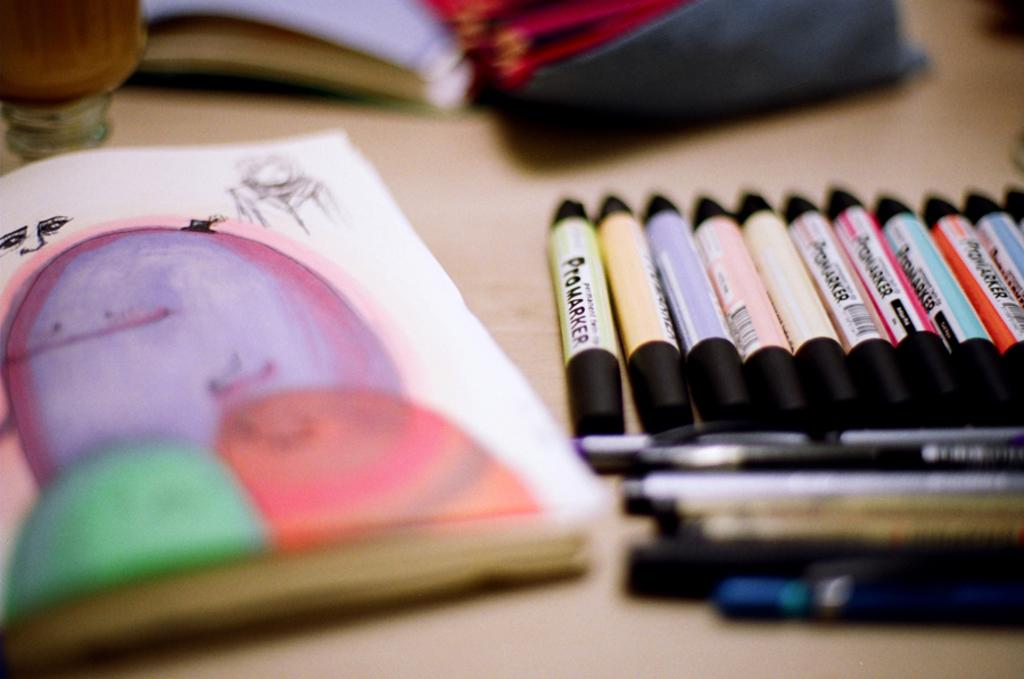Provide a one-sentence caption for the provided image. Various colors of Promarkers are lined up by a colorful drawing. 